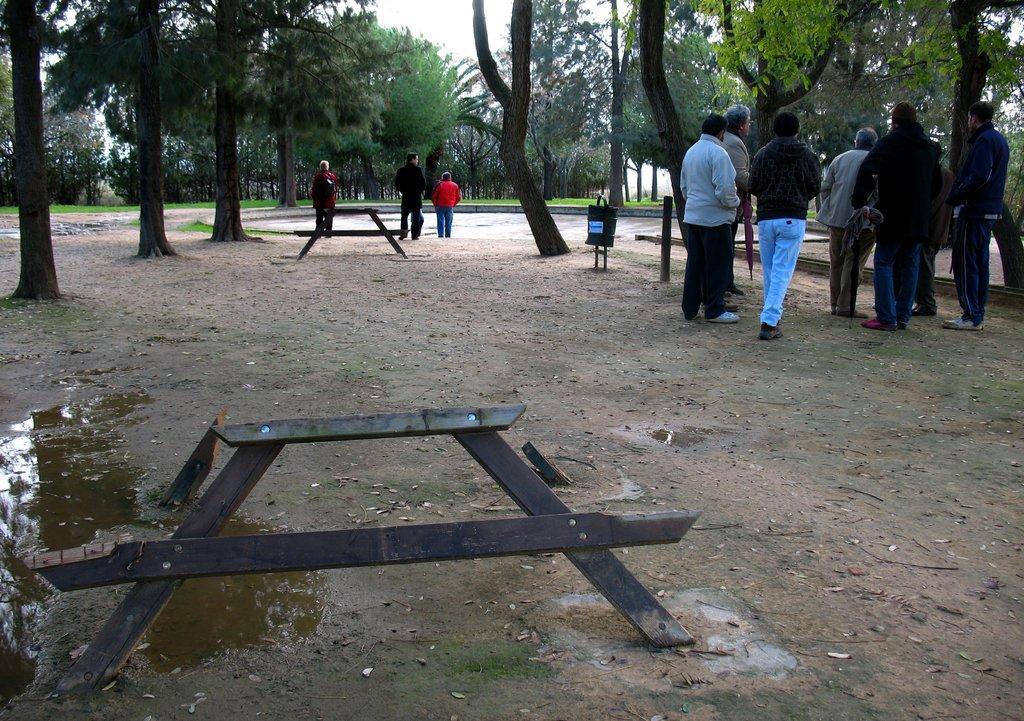Describe this image in one or two sentences. In the image there are few people standing and walking on the land with trees all around the place and above its sky, in the front there is a broken wooden furniture. 